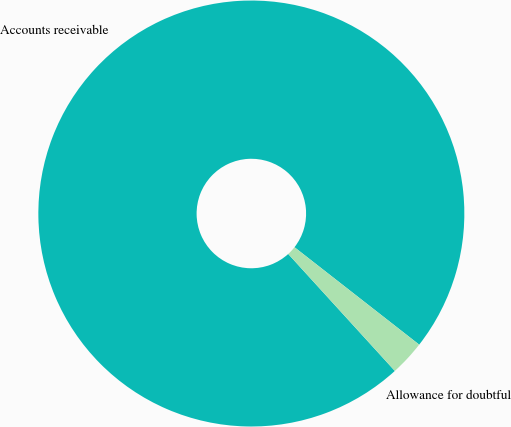Convert chart to OTSL. <chart><loc_0><loc_0><loc_500><loc_500><pie_chart><fcel>Accounts receivable<fcel>Allowance for doubtful<nl><fcel>97.32%<fcel>2.68%<nl></chart> 